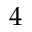Convert formula to latex. <formula><loc_0><loc_0><loc_500><loc_500>4</formula> 